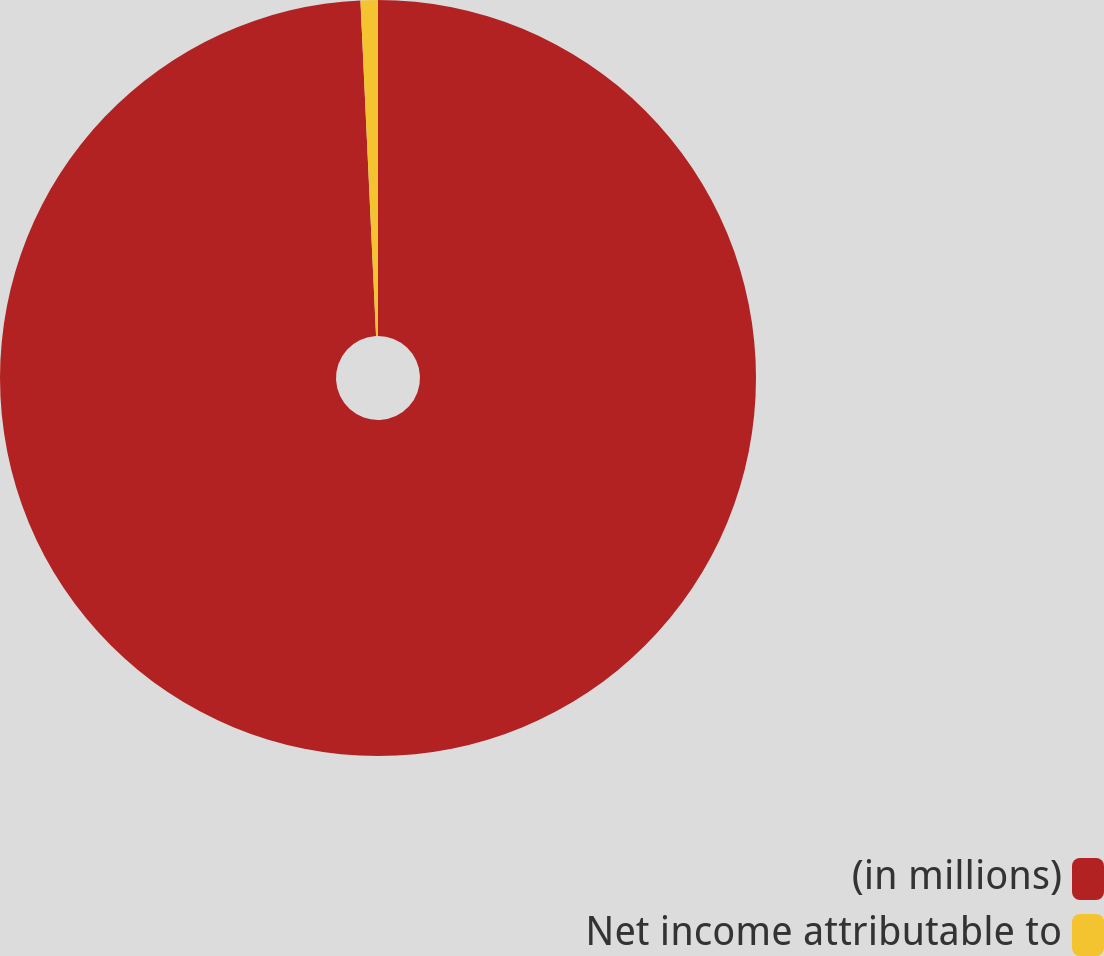<chart> <loc_0><loc_0><loc_500><loc_500><pie_chart><fcel>(in millions)<fcel>Net income attributable to<nl><fcel>99.26%<fcel>0.74%<nl></chart> 